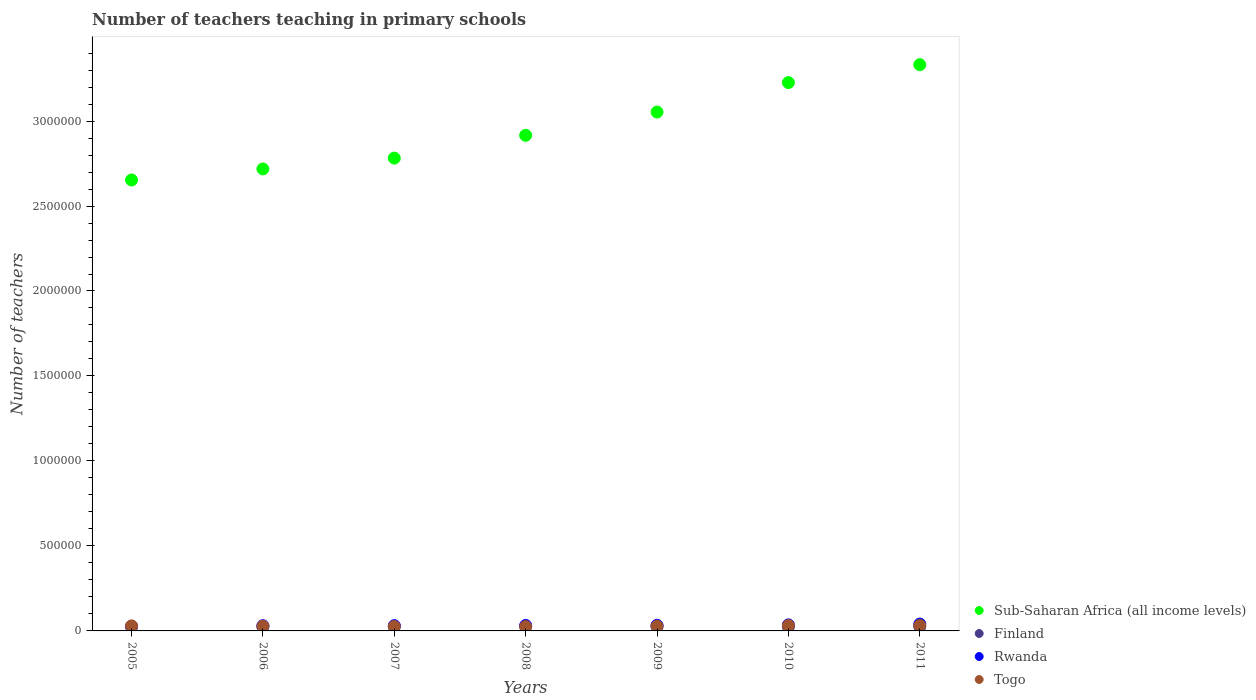How many different coloured dotlines are there?
Provide a succinct answer. 4. What is the number of teachers teaching in primary schools in Togo in 2010?
Your answer should be very brief. 3.17e+04. Across all years, what is the maximum number of teachers teaching in primary schools in Sub-Saharan Africa (all income levels)?
Give a very brief answer. 3.33e+06. Across all years, what is the minimum number of teachers teaching in primary schools in Finland?
Provide a succinct answer. 2.43e+04. In which year was the number of teachers teaching in primary schools in Rwanda maximum?
Offer a terse response. 2011. In which year was the number of teachers teaching in primary schools in Sub-Saharan Africa (all income levels) minimum?
Offer a very short reply. 2005. What is the total number of teachers teaching in primary schools in Rwanda in the graph?
Make the answer very short. 2.30e+05. What is the difference between the number of teachers teaching in primary schools in Togo in 2006 and that in 2010?
Give a very brief answer. -3709. What is the difference between the number of teachers teaching in primary schools in Finland in 2011 and the number of teachers teaching in primary schools in Sub-Saharan Africa (all income levels) in 2010?
Make the answer very short. -3.20e+06. What is the average number of teachers teaching in primary schools in Rwanda per year?
Provide a short and direct response. 3.29e+04. In the year 2010, what is the difference between the number of teachers teaching in primary schools in Finland and number of teachers teaching in primary schools in Togo?
Provide a succinct answer. -6976. What is the ratio of the number of teachers teaching in primary schools in Togo in 2007 to that in 2008?
Provide a succinct answer. 1.02. Is the difference between the number of teachers teaching in primary schools in Finland in 2007 and 2011 greater than the difference between the number of teachers teaching in primary schools in Togo in 2007 and 2011?
Offer a terse response. Yes. What is the difference between the highest and the second highest number of teachers teaching in primary schools in Togo?
Your response must be concise. 31. What is the difference between the highest and the lowest number of teachers teaching in primary schools in Togo?
Make the answer very short. 6205. Is the sum of the number of teachers teaching in primary schools in Sub-Saharan Africa (all income levels) in 2005 and 2009 greater than the maximum number of teachers teaching in primary schools in Rwanda across all years?
Offer a terse response. Yes. Is it the case that in every year, the sum of the number of teachers teaching in primary schools in Rwanda and number of teachers teaching in primary schools in Finland  is greater than the sum of number of teachers teaching in primary schools in Togo and number of teachers teaching in primary schools in Sub-Saharan Africa (all income levels)?
Give a very brief answer. No. Is it the case that in every year, the sum of the number of teachers teaching in primary schools in Finland and number of teachers teaching in primary schools in Togo  is greater than the number of teachers teaching in primary schools in Rwanda?
Your response must be concise. Yes. Is the number of teachers teaching in primary schools in Togo strictly less than the number of teachers teaching in primary schools in Finland over the years?
Give a very brief answer. No. How many dotlines are there?
Your answer should be very brief. 4. How many years are there in the graph?
Offer a terse response. 7. Does the graph contain any zero values?
Keep it short and to the point. No. Does the graph contain grids?
Ensure brevity in your answer.  No. What is the title of the graph?
Make the answer very short. Number of teachers teaching in primary schools. Does "Gambia, The" appear as one of the legend labels in the graph?
Ensure brevity in your answer.  No. What is the label or title of the Y-axis?
Your answer should be very brief. Number of teachers. What is the Number of teachers in Sub-Saharan Africa (all income levels) in 2005?
Provide a succinct answer. 2.65e+06. What is the Number of teachers of Finland in 2005?
Offer a very short reply. 2.46e+04. What is the Number of teachers in Rwanda in 2005?
Provide a short and direct response. 2.69e+04. What is the Number of teachers in Togo in 2005?
Offer a very short reply. 2.97e+04. What is the Number of teachers in Sub-Saharan Africa (all income levels) in 2006?
Your response must be concise. 2.72e+06. What is the Number of teachers of Finland in 2006?
Ensure brevity in your answer.  2.48e+04. What is the Number of teachers of Rwanda in 2006?
Offer a terse response. 3.06e+04. What is the Number of teachers of Togo in 2006?
Keep it short and to the point. 2.80e+04. What is the Number of teachers in Sub-Saharan Africa (all income levels) in 2007?
Offer a terse response. 2.78e+06. What is the Number of teachers of Finland in 2007?
Provide a succinct answer. 2.43e+04. What is the Number of teachers in Rwanda in 2007?
Make the answer very short. 3.10e+04. What is the Number of teachers in Togo in 2007?
Offer a very short reply. 2.61e+04. What is the Number of teachers in Sub-Saharan Africa (all income levels) in 2008?
Your answer should be compact. 2.92e+06. What is the Number of teachers of Finland in 2008?
Offer a very short reply. 2.48e+04. What is the Number of teachers of Rwanda in 2008?
Your answer should be compact. 3.23e+04. What is the Number of teachers of Togo in 2008?
Make the answer very short. 2.55e+04. What is the Number of teachers in Sub-Saharan Africa (all income levels) in 2009?
Offer a very short reply. 3.05e+06. What is the Number of teachers in Finland in 2009?
Your response must be concise. 2.57e+04. What is the Number of teachers in Rwanda in 2009?
Ensure brevity in your answer.  3.32e+04. What is the Number of teachers of Togo in 2009?
Ensure brevity in your answer.  2.82e+04. What is the Number of teachers in Sub-Saharan Africa (all income levels) in 2010?
Provide a succinct answer. 3.23e+06. What is the Number of teachers of Finland in 2010?
Your answer should be very brief. 2.47e+04. What is the Number of teachers of Rwanda in 2010?
Ensure brevity in your answer.  3.56e+04. What is the Number of teachers of Togo in 2010?
Offer a very short reply. 3.17e+04. What is the Number of teachers in Sub-Saharan Africa (all income levels) in 2011?
Make the answer very short. 3.33e+06. What is the Number of teachers in Finland in 2011?
Your answer should be compact. 2.53e+04. What is the Number of teachers in Rwanda in 2011?
Provide a short and direct response. 4.03e+04. What is the Number of teachers in Togo in 2011?
Offer a very short reply. 3.17e+04. Across all years, what is the maximum Number of teachers in Sub-Saharan Africa (all income levels)?
Offer a very short reply. 3.33e+06. Across all years, what is the maximum Number of teachers of Finland?
Your answer should be very brief. 2.57e+04. Across all years, what is the maximum Number of teachers in Rwanda?
Provide a short and direct response. 4.03e+04. Across all years, what is the maximum Number of teachers in Togo?
Provide a succinct answer. 3.17e+04. Across all years, what is the minimum Number of teachers of Sub-Saharan Africa (all income levels)?
Provide a short and direct response. 2.65e+06. Across all years, what is the minimum Number of teachers of Finland?
Your answer should be very brief. 2.43e+04. Across all years, what is the minimum Number of teachers in Rwanda?
Provide a succinct answer. 2.69e+04. Across all years, what is the minimum Number of teachers of Togo?
Offer a terse response. 2.55e+04. What is the total Number of teachers in Sub-Saharan Africa (all income levels) in the graph?
Provide a succinct answer. 2.07e+07. What is the total Number of teachers in Finland in the graph?
Provide a short and direct response. 1.74e+05. What is the total Number of teachers in Rwanda in the graph?
Your answer should be compact. 2.30e+05. What is the total Number of teachers of Togo in the graph?
Offer a terse response. 2.01e+05. What is the difference between the Number of teachers of Sub-Saharan Africa (all income levels) in 2005 and that in 2006?
Your answer should be very brief. -6.51e+04. What is the difference between the Number of teachers of Finland in 2005 and that in 2006?
Make the answer very short. -216. What is the difference between the Number of teachers in Rwanda in 2005 and that in 2006?
Give a very brief answer. -3693. What is the difference between the Number of teachers in Togo in 2005 and that in 2006?
Give a very brief answer. 1665. What is the difference between the Number of teachers in Sub-Saharan Africa (all income levels) in 2005 and that in 2007?
Offer a very short reply. -1.29e+05. What is the difference between the Number of teachers of Finland in 2005 and that in 2007?
Provide a succinct answer. 305. What is the difference between the Number of teachers in Rwanda in 2005 and that in 2007?
Your answer should be compact. -4093. What is the difference between the Number of teachers in Togo in 2005 and that in 2007?
Your answer should be compact. 3565. What is the difference between the Number of teachers of Sub-Saharan Africa (all income levels) in 2005 and that in 2008?
Keep it short and to the point. -2.63e+05. What is the difference between the Number of teachers in Finland in 2005 and that in 2008?
Make the answer very short. -253. What is the difference between the Number of teachers of Rwanda in 2005 and that in 2008?
Your answer should be compact. -5394. What is the difference between the Number of teachers in Togo in 2005 and that in 2008?
Provide a short and direct response. 4130. What is the difference between the Number of teachers in Sub-Saharan Africa (all income levels) in 2005 and that in 2009?
Your answer should be very brief. -4.00e+05. What is the difference between the Number of teachers of Finland in 2005 and that in 2009?
Your answer should be very brief. -1151. What is the difference between the Number of teachers of Rwanda in 2005 and that in 2009?
Offer a terse response. -6214. What is the difference between the Number of teachers of Togo in 2005 and that in 2009?
Provide a succinct answer. 1515. What is the difference between the Number of teachers in Sub-Saharan Africa (all income levels) in 2005 and that in 2010?
Give a very brief answer. -5.73e+05. What is the difference between the Number of teachers of Finland in 2005 and that in 2010?
Keep it short and to the point. -159. What is the difference between the Number of teachers of Rwanda in 2005 and that in 2010?
Provide a succinct answer. -8639. What is the difference between the Number of teachers of Togo in 2005 and that in 2010?
Offer a terse response. -2044. What is the difference between the Number of teachers of Sub-Saharan Africa (all income levels) in 2005 and that in 2011?
Keep it short and to the point. -6.78e+05. What is the difference between the Number of teachers in Finland in 2005 and that in 2011?
Your answer should be compact. -704. What is the difference between the Number of teachers in Rwanda in 2005 and that in 2011?
Make the answer very short. -1.34e+04. What is the difference between the Number of teachers in Togo in 2005 and that in 2011?
Provide a short and direct response. -2075. What is the difference between the Number of teachers in Sub-Saharan Africa (all income levels) in 2006 and that in 2007?
Keep it short and to the point. -6.36e+04. What is the difference between the Number of teachers in Finland in 2006 and that in 2007?
Keep it short and to the point. 521. What is the difference between the Number of teachers of Rwanda in 2006 and that in 2007?
Your answer should be very brief. -400. What is the difference between the Number of teachers of Togo in 2006 and that in 2007?
Keep it short and to the point. 1900. What is the difference between the Number of teachers of Sub-Saharan Africa (all income levels) in 2006 and that in 2008?
Offer a terse response. -1.98e+05. What is the difference between the Number of teachers of Finland in 2006 and that in 2008?
Keep it short and to the point. -37. What is the difference between the Number of teachers in Rwanda in 2006 and that in 2008?
Give a very brief answer. -1701. What is the difference between the Number of teachers of Togo in 2006 and that in 2008?
Ensure brevity in your answer.  2465. What is the difference between the Number of teachers in Sub-Saharan Africa (all income levels) in 2006 and that in 2009?
Your answer should be compact. -3.35e+05. What is the difference between the Number of teachers of Finland in 2006 and that in 2009?
Make the answer very short. -935. What is the difference between the Number of teachers in Rwanda in 2006 and that in 2009?
Your response must be concise. -2521. What is the difference between the Number of teachers of Togo in 2006 and that in 2009?
Your answer should be very brief. -150. What is the difference between the Number of teachers in Sub-Saharan Africa (all income levels) in 2006 and that in 2010?
Give a very brief answer. -5.08e+05. What is the difference between the Number of teachers in Finland in 2006 and that in 2010?
Your answer should be very brief. 57. What is the difference between the Number of teachers in Rwanda in 2006 and that in 2010?
Your answer should be compact. -4946. What is the difference between the Number of teachers of Togo in 2006 and that in 2010?
Your answer should be compact. -3709. What is the difference between the Number of teachers of Sub-Saharan Africa (all income levels) in 2006 and that in 2011?
Your response must be concise. -6.13e+05. What is the difference between the Number of teachers of Finland in 2006 and that in 2011?
Offer a terse response. -488. What is the difference between the Number of teachers of Rwanda in 2006 and that in 2011?
Give a very brief answer. -9662. What is the difference between the Number of teachers of Togo in 2006 and that in 2011?
Offer a very short reply. -3740. What is the difference between the Number of teachers in Sub-Saharan Africa (all income levels) in 2007 and that in 2008?
Offer a terse response. -1.34e+05. What is the difference between the Number of teachers of Finland in 2007 and that in 2008?
Provide a succinct answer. -558. What is the difference between the Number of teachers of Rwanda in 2007 and that in 2008?
Offer a terse response. -1301. What is the difference between the Number of teachers in Togo in 2007 and that in 2008?
Your response must be concise. 565. What is the difference between the Number of teachers of Sub-Saharan Africa (all income levels) in 2007 and that in 2009?
Offer a terse response. -2.71e+05. What is the difference between the Number of teachers of Finland in 2007 and that in 2009?
Your answer should be very brief. -1456. What is the difference between the Number of teachers of Rwanda in 2007 and that in 2009?
Offer a very short reply. -2121. What is the difference between the Number of teachers of Togo in 2007 and that in 2009?
Your answer should be very brief. -2050. What is the difference between the Number of teachers of Sub-Saharan Africa (all income levels) in 2007 and that in 2010?
Your answer should be compact. -4.44e+05. What is the difference between the Number of teachers of Finland in 2007 and that in 2010?
Give a very brief answer. -464. What is the difference between the Number of teachers in Rwanda in 2007 and that in 2010?
Provide a succinct answer. -4546. What is the difference between the Number of teachers of Togo in 2007 and that in 2010?
Provide a short and direct response. -5609. What is the difference between the Number of teachers in Sub-Saharan Africa (all income levels) in 2007 and that in 2011?
Offer a terse response. -5.50e+05. What is the difference between the Number of teachers in Finland in 2007 and that in 2011?
Your answer should be very brief. -1009. What is the difference between the Number of teachers of Rwanda in 2007 and that in 2011?
Offer a terse response. -9262. What is the difference between the Number of teachers of Togo in 2007 and that in 2011?
Your answer should be very brief. -5640. What is the difference between the Number of teachers of Sub-Saharan Africa (all income levels) in 2008 and that in 2009?
Give a very brief answer. -1.37e+05. What is the difference between the Number of teachers in Finland in 2008 and that in 2009?
Your answer should be very brief. -898. What is the difference between the Number of teachers in Rwanda in 2008 and that in 2009?
Ensure brevity in your answer.  -820. What is the difference between the Number of teachers of Togo in 2008 and that in 2009?
Make the answer very short. -2615. What is the difference between the Number of teachers of Sub-Saharan Africa (all income levels) in 2008 and that in 2010?
Give a very brief answer. -3.10e+05. What is the difference between the Number of teachers of Finland in 2008 and that in 2010?
Provide a succinct answer. 94. What is the difference between the Number of teachers of Rwanda in 2008 and that in 2010?
Your response must be concise. -3245. What is the difference between the Number of teachers in Togo in 2008 and that in 2010?
Make the answer very short. -6174. What is the difference between the Number of teachers of Sub-Saharan Africa (all income levels) in 2008 and that in 2011?
Keep it short and to the point. -4.15e+05. What is the difference between the Number of teachers of Finland in 2008 and that in 2011?
Ensure brevity in your answer.  -451. What is the difference between the Number of teachers of Rwanda in 2008 and that in 2011?
Keep it short and to the point. -7961. What is the difference between the Number of teachers of Togo in 2008 and that in 2011?
Provide a succinct answer. -6205. What is the difference between the Number of teachers in Sub-Saharan Africa (all income levels) in 2009 and that in 2010?
Offer a very short reply. -1.73e+05. What is the difference between the Number of teachers in Finland in 2009 and that in 2010?
Offer a terse response. 992. What is the difference between the Number of teachers in Rwanda in 2009 and that in 2010?
Offer a terse response. -2425. What is the difference between the Number of teachers of Togo in 2009 and that in 2010?
Offer a terse response. -3559. What is the difference between the Number of teachers in Sub-Saharan Africa (all income levels) in 2009 and that in 2011?
Keep it short and to the point. -2.79e+05. What is the difference between the Number of teachers of Finland in 2009 and that in 2011?
Your answer should be very brief. 447. What is the difference between the Number of teachers of Rwanda in 2009 and that in 2011?
Make the answer very short. -7141. What is the difference between the Number of teachers in Togo in 2009 and that in 2011?
Provide a short and direct response. -3590. What is the difference between the Number of teachers in Sub-Saharan Africa (all income levels) in 2010 and that in 2011?
Provide a short and direct response. -1.05e+05. What is the difference between the Number of teachers of Finland in 2010 and that in 2011?
Your answer should be very brief. -545. What is the difference between the Number of teachers in Rwanda in 2010 and that in 2011?
Your answer should be very brief. -4716. What is the difference between the Number of teachers in Togo in 2010 and that in 2011?
Keep it short and to the point. -31. What is the difference between the Number of teachers of Sub-Saharan Africa (all income levels) in 2005 and the Number of teachers of Finland in 2006?
Provide a short and direct response. 2.63e+06. What is the difference between the Number of teachers of Sub-Saharan Africa (all income levels) in 2005 and the Number of teachers of Rwanda in 2006?
Your response must be concise. 2.62e+06. What is the difference between the Number of teachers in Sub-Saharan Africa (all income levels) in 2005 and the Number of teachers in Togo in 2006?
Your answer should be very brief. 2.63e+06. What is the difference between the Number of teachers of Finland in 2005 and the Number of teachers of Rwanda in 2006?
Give a very brief answer. -6060. What is the difference between the Number of teachers of Finland in 2005 and the Number of teachers of Togo in 2006?
Keep it short and to the point. -3426. What is the difference between the Number of teachers in Rwanda in 2005 and the Number of teachers in Togo in 2006?
Keep it short and to the point. -1059. What is the difference between the Number of teachers in Sub-Saharan Africa (all income levels) in 2005 and the Number of teachers in Finland in 2007?
Make the answer very short. 2.63e+06. What is the difference between the Number of teachers in Sub-Saharan Africa (all income levels) in 2005 and the Number of teachers in Rwanda in 2007?
Offer a terse response. 2.62e+06. What is the difference between the Number of teachers of Sub-Saharan Africa (all income levels) in 2005 and the Number of teachers of Togo in 2007?
Make the answer very short. 2.63e+06. What is the difference between the Number of teachers in Finland in 2005 and the Number of teachers in Rwanda in 2007?
Offer a very short reply. -6460. What is the difference between the Number of teachers in Finland in 2005 and the Number of teachers in Togo in 2007?
Give a very brief answer. -1526. What is the difference between the Number of teachers of Rwanda in 2005 and the Number of teachers of Togo in 2007?
Provide a succinct answer. 841. What is the difference between the Number of teachers of Sub-Saharan Africa (all income levels) in 2005 and the Number of teachers of Finland in 2008?
Your answer should be very brief. 2.63e+06. What is the difference between the Number of teachers of Sub-Saharan Africa (all income levels) in 2005 and the Number of teachers of Rwanda in 2008?
Your response must be concise. 2.62e+06. What is the difference between the Number of teachers in Sub-Saharan Africa (all income levels) in 2005 and the Number of teachers in Togo in 2008?
Your answer should be compact. 2.63e+06. What is the difference between the Number of teachers of Finland in 2005 and the Number of teachers of Rwanda in 2008?
Provide a succinct answer. -7761. What is the difference between the Number of teachers of Finland in 2005 and the Number of teachers of Togo in 2008?
Keep it short and to the point. -961. What is the difference between the Number of teachers in Rwanda in 2005 and the Number of teachers in Togo in 2008?
Give a very brief answer. 1406. What is the difference between the Number of teachers in Sub-Saharan Africa (all income levels) in 2005 and the Number of teachers in Finland in 2009?
Make the answer very short. 2.63e+06. What is the difference between the Number of teachers in Sub-Saharan Africa (all income levels) in 2005 and the Number of teachers in Rwanda in 2009?
Your answer should be very brief. 2.62e+06. What is the difference between the Number of teachers of Sub-Saharan Africa (all income levels) in 2005 and the Number of teachers of Togo in 2009?
Offer a terse response. 2.63e+06. What is the difference between the Number of teachers of Finland in 2005 and the Number of teachers of Rwanda in 2009?
Give a very brief answer. -8581. What is the difference between the Number of teachers in Finland in 2005 and the Number of teachers in Togo in 2009?
Provide a short and direct response. -3576. What is the difference between the Number of teachers of Rwanda in 2005 and the Number of teachers of Togo in 2009?
Offer a terse response. -1209. What is the difference between the Number of teachers in Sub-Saharan Africa (all income levels) in 2005 and the Number of teachers in Finland in 2010?
Your response must be concise. 2.63e+06. What is the difference between the Number of teachers in Sub-Saharan Africa (all income levels) in 2005 and the Number of teachers in Rwanda in 2010?
Ensure brevity in your answer.  2.62e+06. What is the difference between the Number of teachers in Sub-Saharan Africa (all income levels) in 2005 and the Number of teachers in Togo in 2010?
Ensure brevity in your answer.  2.62e+06. What is the difference between the Number of teachers of Finland in 2005 and the Number of teachers of Rwanda in 2010?
Make the answer very short. -1.10e+04. What is the difference between the Number of teachers of Finland in 2005 and the Number of teachers of Togo in 2010?
Ensure brevity in your answer.  -7135. What is the difference between the Number of teachers in Rwanda in 2005 and the Number of teachers in Togo in 2010?
Provide a succinct answer. -4768. What is the difference between the Number of teachers of Sub-Saharan Africa (all income levels) in 2005 and the Number of teachers of Finland in 2011?
Offer a very short reply. 2.63e+06. What is the difference between the Number of teachers of Sub-Saharan Africa (all income levels) in 2005 and the Number of teachers of Rwanda in 2011?
Make the answer very short. 2.61e+06. What is the difference between the Number of teachers of Sub-Saharan Africa (all income levels) in 2005 and the Number of teachers of Togo in 2011?
Your answer should be very brief. 2.62e+06. What is the difference between the Number of teachers of Finland in 2005 and the Number of teachers of Rwanda in 2011?
Offer a very short reply. -1.57e+04. What is the difference between the Number of teachers in Finland in 2005 and the Number of teachers in Togo in 2011?
Provide a succinct answer. -7166. What is the difference between the Number of teachers of Rwanda in 2005 and the Number of teachers of Togo in 2011?
Make the answer very short. -4799. What is the difference between the Number of teachers of Sub-Saharan Africa (all income levels) in 2006 and the Number of teachers of Finland in 2007?
Provide a short and direct response. 2.69e+06. What is the difference between the Number of teachers of Sub-Saharan Africa (all income levels) in 2006 and the Number of teachers of Rwanda in 2007?
Offer a very short reply. 2.69e+06. What is the difference between the Number of teachers in Sub-Saharan Africa (all income levels) in 2006 and the Number of teachers in Togo in 2007?
Ensure brevity in your answer.  2.69e+06. What is the difference between the Number of teachers in Finland in 2006 and the Number of teachers in Rwanda in 2007?
Make the answer very short. -6244. What is the difference between the Number of teachers of Finland in 2006 and the Number of teachers of Togo in 2007?
Keep it short and to the point. -1310. What is the difference between the Number of teachers of Rwanda in 2006 and the Number of teachers of Togo in 2007?
Give a very brief answer. 4534. What is the difference between the Number of teachers of Sub-Saharan Africa (all income levels) in 2006 and the Number of teachers of Finland in 2008?
Provide a succinct answer. 2.69e+06. What is the difference between the Number of teachers of Sub-Saharan Africa (all income levels) in 2006 and the Number of teachers of Rwanda in 2008?
Provide a succinct answer. 2.69e+06. What is the difference between the Number of teachers in Sub-Saharan Africa (all income levels) in 2006 and the Number of teachers in Togo in 2008?
Make the answer very short. 2.69e+06. What is the difference between the Number of teachers in Finland in 2006 and the Number of teachers in Rwanda in 2008?
Your response must be concise. -7545. What is the difference between the Number of teachers of Finland in 2006 and the Number of teachers of Togo in 2008?
Offer a very short reply. -745. What is the difference between the Number of teachers of Rwanda in 2006 and the Number of teachers of Togo in 2008?
Give a very brief answer. 5099. What is the difference between the Number of teachers of Sub-Saharan Africa (all income levels) in 2006 and the Number of teachers of Finland in 2009?
Your response must be concise. 2.69e+06. What is the difference between the Number of teachers of Sub-Saharan Africa (all income levels) in 2006 and the Number of teachers of Rwanda in 2009?
Provide a short and direct response. 2.69e+06. What is the difference between the Number of teachers of Sub-Saharan Africa (all income levels) in 2006 and the Number of teachers of Togo in 2009?
Make the answer very short. 2.69e+06. What is the difference between the Number of teachers of Finland in 2006 and the Number of teachers of Rwanda in 2009?
Provide a succinct answer. -8365. What is the difference between the Number of teachers of Finland in 2006 and the Number of teachers of Togo in 2009?
Your answer should be compact. -3360. What is the difference between the Number of teachers in Rwanda in 2006 and the Number of teachers in Togo in 2009?
Give a very brief answer. 2484. What is the difference between the Number of teachers of Sub-Saharan Africa (all income levels) in 2006 and the Number of teachers of Finland in 2010?
Give a very brief answer. 2.69e+06. What is the difference between the Number of teachers in Sub-Saharan Africa (all income levels) in 2006 and the Number of teachers in Rwanda in 2010?
Your answer should be very brief. 2.68e+06. What is the difference between the Number of teachers of Sub-Saharan Africa (all income levels) in 2006 and the Number of teachers of Togo in 2010?
Keep it short and to the point. 2.69e+06. What is the difference between the Number of teachers in Finland in 2006 and the Number of teachers in Rwanda in 2010?
Offer a very short reply. -1.08e+04. What is the difference between the Number of teachers in Finland in 2006 and the Number of teachers in Togo in 2010?
Offer a terse response. -6919. What is the difference between the Number of teachers in Rwanda in 2006 and the Number of teachers in Togo in 2010?
Offer a terse response. -1075. What is the difference between the Number of teachers of Sub-Saharan Africa (all income levels) in 2006 and the Number of teachers of Finland in 2011?
Your answer should be compact. 2.69e+06. What is the difference between the Number of teachers in Sub-Saharan Africa (all income levels) in 2006 and the Number of teachers in Rwanda in 2011?
Your answer should be compact. 2.68e+06. What is the difference between the Number of teachers in Sub-Saharan Africa (all income levels) in 2006 and the Number of teachers in Togo in 2011?
Your answer should be very brief. 2.69e+06. What is the difference between the Number of teachers of Finland in 2006 and the Number of teachers of Rwanda in 2011?
Your response must be concise. -1.55e+04. What is the difference between the Number of teachers in Finland in 2006 and the Number of teachers in Togo in 2011?
Keep it short and to the point. -6950. What is the difference between the Number of teachers of Rwanda in 2006 and the Number of teachers of Togo in 2011?
Provide a succinct answer. -1106. What is the difference between the Number of teachers of Sub-Saharan Africa (all income levels) in 2007 and the Number of teachers of Finland in 2008?
Ensure brevity in your answer.  2.76e+06. What is the difference between the Number of teachers in Sub-Saharan Africa (all income levels) in 2007 and the Number of teachers in Rwanda in 2008?
Offer a terse response. 2.75e+06. What is the difference between the Number of teachers of Sub-Saharan Africa (all income levels) in 2007 and the Number of teachers of Togo in 2008?
Provide a short and direct response. 2.76e+06. What is the difference between the Number of teachers in Finland in 2007 and the Number of teachers in Rwanda in 2008?
Your answer should be compact. -8066. What is the difference between the Number of teachers in Finland in 2007 and the Number of teachers in Togo in 2008?
Keep it short and to the point. -1266. What is the difference between the Number of teachers of Rwanda in 2007 and the Number of teachers of Togo in 2008?
Provide a succinct answer. 5499. What is the difference between the Number of teachers in Sub-Saharan Africa (all income levels) in 2007 and the Number of teachers in Finland in 2009?
Provide a short and direct response. 2.76e+06. What is the difference between the Number of teachers of Sub-Saharan Africa (all income levels) in 2007 and the Number of teachers of Rwanda in 2009?
Offer a very short reply. 2.75e+06. What is the difference between the Number of teachers of Sub-Saharan Africa (all income levels) in 2007 and the Number of teachers of Togo in 2009?
Your answer should be very brief. 2.75e+06. What is the difference between the Number of teachers of Finland in 2007 and the Number of teachers of Rwanda in 2009?
Keep it short and to the point. -8886. What is the difference between the Number of teachers in Finland in 2007 and the Number of teachers in Togo in 2009?
Provide a succinct answer. -3881. What is the difference between the Number of teachers in Rwanda in 2007 and the Number of teachers in Togo in 2009?
Your response must be concise. 2884. What is the difference between the Number of teachers of Sub-Saharan Africa (all income levels) in 2007 and the Number of teachers of Finland in 2010?
Offer a terse response. 2.76e+06. What is the difference between the Number of teachers in Sub-Saharan Africa (all income levels) in 2007 and the Number of teachers in Rwanda in 2010?
Provide a short and direct response. 2.75e+06. What is the difference between the Number of teachers in Sub-Saharan Africa (all income levels) in 2007 and the Number of teachers in Togo in 2010?
Make the answer very short. 2.75e+06. What is the difference between the Number of teachers in Finland in 2007 and the Number of teachers in Rwanda in 2010?
Keep it short and to the point. -1.13e+04. What is the difference between the Number of teachers in Finland in 2007 and the Number of teachers in Togo in 2010?
Provide a succinct answer. -7440. What is the difference between the Number of teachers in Rwanda in 2007 and the Number of teachers in Togo in 2010?
Your answer should be compact. -675. What is the difference between the Number of teachers in Sub-Saharan Africa (all income levels) in 2007 and the Number of teachers in Finland in 2011?
Provide a succinct answer. 2.76e+06. What is the difference between the Number of teachers of Sub-Saharan Africa (all income levels) in 2007 and the Number of teachers of Rwanda in 2011?
Offer a terse response. 2.74e+06. What is the difference between the Number of teachers in Sub-Saharan Africa (all income levels) in 2007 and the Number of teachers in Togo in 2011?
Give a very brief answer. 2.75e+06. What is the difference between the Number of teachers of Finland in 2007 and the Number of teachers of Rwanda in 2011?
Your answer should be compact. -1.60e+04. What is the difference between the Number of teachers of Finland in 2007 and the Number of teachers of Togo in 2011?
Offer a terse response. -7471. What is the difference between the Number of teachers of Rwanda in 2007 and the Number of teachers of Togo in 2011?
Your response must be concise. -706. What is the difference between the Number of teachers of Sub-Saharan Africa (all income levels) in 2008 and the Number of teachers of Finland in 2009?
Offer a very short reply. 2.89e+06. What is the difference between the Number of teachers of Sub-Saharan Africa (all income levels) in 2008 and the Number of teachers of Rwanda in 2009?
Keep it short and to the point. 2.88e+06. What is the difference between the Number of teachers in Sub-Saharan Africa (all income levels) in 2008 and the Number of teachers in Togo in 2009?
Your answer should be compact. 2.89e+06. What is the difference between the Number of teachers of Finland in 2008 and the Number of teachers of Rwanda in 2009?
Provide a short and direct response. -8328. What is the difference between the Number of teachers in Finland in 2008 and the Number of teachers in Togo in 2009?
Offer a very short reply. -3323. What is the difference between the Number of teachers of Rwanda in 2008 and the Number of teachers of Togo in 2009?
Offer a terse response. 4185. What is the difference between the Number of teachers of Sub-Saharan Africa (all income levels) in 2008 and the Number of teachers of Finland in 2010?
Provide a short and direct response. 2.89e+06. What is the difference between the Number of teachers in Sub-Saharan Africa (all income levels) in 2008 and the Number of teachers in Rwanda in 2010?
Your response must be concise. 2.88e+06. What is the difference between the Number of teachers of Sub-Saharan Africa (all income levels) in 2008 and the Number of teachers of Togo in 2010?
Provide a succinct answer. 2.88e+06. What is the difference between the Number of teachers in Finland in 2008 and the Number of teachers in Rwanda in 2010?
Make the answer very short. -1.08e+04. What is the difference between the Number of teachers in Finland in 2008 and the Number of teachers in Togo in 2010?
Provide a short and direct response. -6882. What is the difference between the Number of teachers of Rwanda in 2008 and the Number of teachers of Togo in 2010?
Keep it short and to the point. 626. What is the difference between the Number of teachers in Sub-Saharan Africa (all income levels) in 2008 and the Number of teachers in Finland in 2011?
Provide a succinct answer. 2.89e+06. What is the difference between the Number of teachers in Sub-Saharan Africa (all income levels) in 2008 and the Number of teachers in Rwanda in 2011?
Your answer should be very brief. 2.88e+06. What is the difference between the Number of teachers in Sub-Saharan Africa (all income levels) in 2008 and the Number of teachers in Togo in 2011?
Keep it short and to the point. 2.88e+06. What is the difference between the Number of teachers of Finland in 2008 and the Number of teachers of Rwanda in 2011?
Your answer should be compact. -1.55e+04. What is the difference between the Number of teachers in Finland in 2008 and the Number of teachers in Togo in 2011?
Give a very brief answer. -6913. What is the difference between the Number of teachers in Rwanda in 2008 and the Number of teachers in Togo in 2011?
Provide a short and direct response. 595. What is the difference between the Number of teachers in Sub-Saharan Africa (all income levels) in 2009 and the Number of teachers in Finland in 2010?
Give a very brief answer. 3.03e+06. What is the difference between the Number of teachers in Sub-Saharan Africa (all income levels) in 2009 and the Number of teachers in Rwanda in 2010?
Make the answer very short. 3.02e+06. What is the difference between the Number of teachers of Sub-Saharan Africa (all income levels) in 2009 and the Number of teachers of Togo in 2010?
Give a very brief answer. 3.02e+06. What is the difference between the Number of teachers of Finland in 2009 and the Number of teachers of Rwanda in 2010?
Your response must be concise. -9855. What is the difference between the Number of teachers of Finland in 2009 and the Number of teachers of Togo in 2010?
Give a very brief answer. -5984. What is the difference between the Number of teachers in Rwanda in 2009 and the Number of teachers in Togo in 2010?
Provide a short and direct response. 1446. What is the difference between the Number of teachers in Sub-Saharan Africa (all income levels) in 2009 and the Number of teachers in Finland in 2011?
Offer a very short reply. 3.03e+06. What is the difference between the Number of teachers in Sub-Saharan Africa (all income levels) in 2009 and the Number of teachers in Rwanda in 2011?
Ensure brevity in your answer.  3.01e+06. What is the difference between the Number of teachers in Sub-Saharan Africa (all income levels) in 2009 and the Number of teachers in Togo in 2011?
Offer a terse response. 3.02e+06. What is the difference between the Number of teachers in Finland in 2009 and the Number of teachers in Rwanda in 2011?
Give a very brief answer. -1.46e+04. What is the difference between the Number of teachers of Finland in 2009 and the Number of teachers of Togo in 2011?
Provide a short and direct response. -6015. What is the difference between the Number of teachers in Rwanda in 2009 and the Number of teachers in Togo in 2011?
Ensure brevity in your answer.  1415. What is the difference between the Number of teachers in Sub-Saharan Africa (all income levels) in 2010 and the Number of teachers in Finland in 2011?
Provide a succinct answer. 3.20e+06. What is the difference between the Number of teachers in Sub-Saharan Africa (all income levels) in 2010 and the Number of teachers in Rwanda in 2011?
Ensure brevity in your answer.  3.19e+06. What is the difference between the Number of teachers of Sub-Saharan Africa (all income levels) in 2010 and the Number of teachers of Togo in 2011?
Ensure brevity in your answer.  3.19e+06. What is the difference between the Number of teachers of Finland in 2010 and the Number of teachers of Rwanda in 2011?
Give a very brief answer. -1.56e+04. What is the difference between the Number of teachers in Finland in 2010 and the Number of teachers in Togo in 2011?
Keep it short and to the point. -7007. What is the difference between the Number of teachers in Rwanda in 2010 and the Number of teachers in Togo in 2011?
Ensure brevity in your answer.  3840. What is the average Number of teachers of Sub-Saharan Africa (all income levels) per year?
Make the answer very short. 2.95e+06. What is the average Number of teachers in Finland per year?
Keep it short and to the point. 2.49e+04. What is the average Number of teachers in Rwanda per year?
Your answer should be compact. 3.29e+04. What is the average Number of teachers of Togo per year?
Your response must be concise. 2.87e+04. In the year 2005, what is the difference between the Number of teachers of Sub-Saharan Africa (all income levels) and Number of teachers of Finland?
Your answer should be compact. 2.63e+06. In the year 2005, what is the difference between the Number of teachers of Sub-Saharan Africa (all income levels) and Number of teachers of Rwanda?
Offer a terse response. 2.63e+06. In the year 2005, what is the difference between the Number of teachers in Sub-Saharan Africa (all income levels) and Number of teachers in Togo?
Make the answer very short. 2.62e+06. In the year 2005, what is the difference between the Number of teachers in Finland and Number of teachers in Rwanda?
Your answer should be very brief. -2367. In the year 2005, what is the difference between the Number of teachers of Finland and Number of teachers of Togo?
Provide a succinct answer. -5091. In the year 2005, what is the difference between the Number of teachers in Rwanda and Number of teachers in Togo?
Provide a short and direct response. -2724. In the year 2006, what is the difference between the Number of teachers of Sub-Saharan Africa (all income levels) and Number of teachers of Finland?
Make the answer very short. 2.69e+06. In the year 2006, what is the difference between the Number of teachers in Sub-Saharan Africa (all income levels) and Number of teachers in Rwanda?
Your answer should be very brief. 2.69e+06. In the year 2006, what is the difference between the Number of teachers in Sub-Saharan Africa (all income levels) and Number of teachers in Togo?
Your answer should be compact. 2.69e+06. In the year 2006, what is the difference between the Number of teachers of Finland and Number of teachers of Rwanda?
Ensure brevity in your answer.  -5844. In the year 2006, what is the difference between the Number of teachers of Finland and Number of teachers of Togo?
Your response must be concise. -3210. In the year 2006, what is the difference between the Number of teachers of Rwanda and Number of teachers of Togo?
Your answer should be very brief. 2634. In the year 2007, what is the difference between the Number of teachers in Sub-Saharan Africa (all income levels) and Number of teachers in Finland?
Your response must be concise. 2.76e+06. In the year 2007, what is the difference between the Number of teachers in Sub-Saharan Africa (all income levels) and Number of teachers in Rwanda?
Provide a succinct answer. 2.75e+06. In the year 2007, what is the difference between the Number of teachers in Sub-Saharan Africa (all income levels) and Number of teachers in Togo?
Provide a short and direct response. 2.76e+06. In the year 2007, what is the difference between the Number of teachers of Finland and Number of teachers of Rwanda?
Offer a terse response. -6765. In the year 2007, what is the difference between the Number of teachers in Finland and Number of teachers in Togo?
Keep it short and to the point. -1831. In the year 2007, what is the difference between the Number of teachers in Rwanda and Number of teachers in Togo?
Ensure brevity in your answer.  4934. In the year 2008, what is the difference between the Number of teachers of Sub-Saharan Africa (all income levels) and Number of teachers of Finland?
Your answer should be very brief. 2.89e+06. In the year 2008, what is the difference between the Number of teachers in Sub-Saharan Africa (all income levels) and Number of teachers in Rwanda?
Your response must be concise. 2.88e+06. In the year 2008, what is the difference between the Number of teachers in Sub-Saharan Africa (all income levels) and Number of teachers in Togo?
Your response must be concise. 2.89e+06. In the year 2008, what is the difference between the Number of teachers of Finland and Number of teachers of Rwanda?
Your answer should be compact. -7508. In the year 2008, what is the difference between the Number of teachers of Finland and Number of teachers of Togo?
Your answer should be compact. -708. In the year 2008, what is the difference between the Number of teachers in Rwanda and Number of teachers in Togo?
Your answer should be compact. 6800. In the year 2009, what is the difference between the Number of teachers in Sub-Saharan Africa (all income levels) and Number of teachers in Finland?
Your answer should be compact. 3.03e+06. In the year 2009, what is the difference between the Number of teachers in Sub-Saharan Africa (all income levels) and Number of teachers in Rwanda?
Make the answer very short. 3.02e+06. In the year 2009, what is the difference between the Number of teachers of Sub-Saharan Africa (all income levels) and Number of teachers of Togo?
Provide a succinct answer. 3.02e+06. In the year 2009, what is the difference between the Number of teachers in Finland and Number of teachers in Rwanda?
Offer a terse response. -7430. In the year 2009, what is the difference between the Number of teachers in Finland and Number of teachers in Togo?
Provide a short and direct response. -2425. In the year 2009, what is the difference between the Number of teachers of Rwanda and Number of teachers of Togo?
Your answer should be compact. 5005. In the year 2010, what is the difference between the Number of teachers of Sub-Saharan Africa (all income levels) and Number of teachers of Finland?
Offer a terse response. 3.20e+06. In the year 2010, what is the difference between the Number of teachers in Sub-Saharan Africa (all income levels) and Number of teachers in Rwanda?
Your answer should be very brief. 3.19e+06. In the year 2010, what is the difference between the Number of teachers in Sub-Saharan Africa (all income levels) and Number of teachers in Togo?
Keep it short and to the point. 3.19e+06. In the year 2010, what is the difference between the Number of teachers of Finland and Number of teachers of Rwanda?
Keep it short and to the point. -1.08e+04. In the year 2010, what is the difference between the Number of teachers in Finland and Number of teachers in Togo?
Keep it short and to the point. -6976. In the year 2010, what is the difference between the Number of teachers in Rwanda and Number of teachers in Togo?
Provide a short and direct response. 3871. In the year 2011, what is the difference between the Number of teachers in Sub-Saharan Africa (all income levels) and Number of teachers in Finland?
Offer a terse response. 3.31e+06. In the year 2011, what is the difference between the Number of teachers in Sub-Saharan Africa (all income levels) and Number of teachers in Rwanda?
Make the answer very short. 3.29e+06. In the year 2011, what is the difference between the Number of teachers in Sub-Saharan Africa (all income levels) and Number of teachers in Togo?
Your answer should be very brief. 3.30e+06. In the year 2011, what is the difference between the Number of teachers of Finland and Number of teachers of Rwanda?
Your answer should be compact. -1.50e+04. In the year 2011, what is the difference between the Number of teachers of Finland and Number of teachers of Togo?
Offer a very short reply. -6462. In the year 2011, what is the difference between the Number of teachers of Rwanda and Number of teachers of Togo?
Offer a very short reply. 8556. What is the ratio of the Number of teachers of Sub-Saharan Africa (all income levels) in 2005 to that in 2006?
Ensure brevity in your answer.  0.98. What is the ratio of the Number of teachers in Finland in 2005 to that in 2006?
Your answer should be compact. 0.99. What is the ratio of the Number of teachers in Rwanda in 2005 to that in 2006?
Make the answer very short. 0.88. What is the ratio of the Number of teachers of Togo in 2005 to that in 2006?
Provide a short and direct response. 1.06. What is the ratio of the Number of teachers of Sub-Saharan Africa (all income levels) in 2005 to that in 2007?
Ensure brevity in your answer.  0.95. What is the ratio of the Number of teachers of Finland in 2005 to that in 2007?
Give a very brief answer. 1.01. What is the ratio of the Number of teachers of Rwanda in 2005 to that in 2007?
Make the answer very short. 0.87. What is the ratio of the Number of teachers of Togo in 2005 to that in 2007?
Offer a terse response. 1.14. What is the ratio of the Number of teachers in Sub-Saharan Africa (all income levels) in 2005 to that in 2008?
Give a very brief answer. 0.91. What is the ratio of the Number of teachers of Finland in 2005 to that in 2008?
Offer a terse response. 0.99. What is the ratio of the Number of teachers in Rwanda in 2005 to that in 2008?
Your response must be concise. 0.83. What is the ratio of the Number of teachers of Togo in 2005 to that in 2008?
Ensure brevity in your answer.  1.16. What is the ratio of the Number of teachers of Sub-Saharan Africa (all income levels) in 2005 to that in 2009?
Provide a succinct answer. 0.87. What is the ratio of the Number of teachers in Finland in 2005 to that in 2009?
Your response must be concise. 0.96. What is the ratio of the Number of teachers of Rwanda in 2005 to that in 2009?
Offer a very short reply. 0.81. What is the ratio of the Number of teachers of Togo in 2005 to that in 2009?
Give a very brief answer. 1.05. What is the ratio of the Number of teachers of Sub-Saharan Africa (all income levels) in 2005 to that in 2010?
Offer a terse response. 0.82. What is the ratio of the Number of teachers of Finland in 2005 to that in 2010?
Offer a terse response. 0.99. What is the ratio of the Number of teachers in Rwanda in 2005 to that in 2010?
Provide a short and direct response. 0.76. What is the ratio of the Number of teachers in Togo in 2005 to that in 2010?
Ensure brevity in your answer.  0.94. What is the ratio of the Number of teachers of Sub-Saharan Africa (all income levels) in 2005 to that in 2011?
Offer a very short reply. 0.8. What is the ratio of the Number of teachers in Finland in 2005 to that in 2011?
Provide a succinct answer. 0.97. What is the ratio of the Number of teachers in Rwanda in 2005 to that in 2011?
Make the answer very short. 0.67. What is the ratio of the Number of teachers of Togo in 2005 to that in 2011?
Ensure brevity in your answer.  0.93. What is the ratio of the Number of teachers of Sub-Saharan Africa (all income levels) in 2006 to that in 2007?
Provide a short and direct response. 0.98. What is the ratio of the Number of teachers in Finland in 2006 to that in 2007?
Your response must be concise. 1.02. What is the ratio of the Number of teachers in Rwanda in 2006 to that in 2007?
Offer a terse response. 0.99. What is the ratio of the Number of teachers in Togo in 2006 to that in 2007?
Your answer should be compact. 1.07. What is the ratio of the Number of teachers in Sub-Saharan Africa (all income levels) in 2006 to that in 2008?
Provide a succinct answer. 0.93. What is the ratio of the Number of teachers in Finland in 2006 to that in 2008?
Your response must be concise. 1. What is the ratio of the Number of teachers in Rwanda in 2006 to that in 2008?
Make the answer very short. 0.95. What is the ratio of the Number of teachers in Togo in 2006 to that in 2008?
Keep it short and to the point. 1.1. What is the ratio of the Number of teachers in Sub-Saharan Africa (all income levels) in 2006 to that in 2009?
Keep it short and to the point. 0.89. What is the ratio of the Number of teachers of Finland in 2006 to that in 2009?
Your response must be concise. 0.96. What is the ratio of the Number of teachers of Rwanda in 2006 to that in 2009?
Your answer should be very brief. 0.92. What is the ratio of the Number of teachers of Togo in 2006 to that in 2009?
Your answer should be very brief. 0.99. What is the ratio of the Number of teachers of Sub-Saharan Africa (all income levels) in 2006 to that in 2010?
Keep it short and to the point. 0.84. What is the ratio of the Number of teachers in Finland in 2006 to that in 2010?
Your response must be concise. 1. What is the ratio of the Number of teachers of Rwanda in 2006 to that in 2010?
Your answer should be compact. 0.86. What is the ratio of the Number of teachers in Togo in 2006 to that in 2010?
Provide a succinct answer. 0.88. What is the ratio of the Number of teachers of Sub-Saharan Africa (all income levels) in 2006 to that in 2011?
Give a very brief answer. 0.82. What is the ratio of the Number of teachers in Finland in 2006 to that in 2011?
Offer a very short reply. 0.98. What is the ratio of the Number of teachers of Rwanda in 2006 to that in 2011?
Ensure brevity in your answer.  0.76. What is the ratio of the Number of teachers in Togo in 2006 to that in 2011?
Ensure brevity in your answer.  0.88. What is the ratio of the Number of teachers in Sub-Saharan Africa (all income levels) in 2007 to that in 2008?
Make the answer very short. 0.95. What is the ratio of the Number of teachers of Finland in 2007 to that in 2008?
Provide a short and direct response. 0.98. What is the ratio of the Number of teachers of Rwanda in 2007 to that in 2008?
Your response must be concise. 0.96. What is the ratio of the Number of teachers of Togo in 2007 to that in 2008?
Offer a very short reply. 1.02. What is the ratio of the Number of teachers of Sub-Saharan Africa (all income levels) in 2007 to that in 2009?
Your answer should be compact. 0.91. What is the ratio of the Number of teachers in Finland in 2007 to that in 2009?
Offer a very short reply. 0.94. What is the ratio of the Number of teachers in Rwanda in 2007 to that in 2009?
Make the answer very short. 0.94. What is the ratio of the Number of teachers in Togo in 2007 to that in 2009?
Give a very brief answer. 0.93. What is the ratio of the Number of teachers of Sub-Saharan Africa (all income levels) in 2007 to that in 2010?
Provide a succinct answer. 0.86. What is the ratio of the Number of teachers in Finland in 2007 to that in 2010?
Your answer should be compact. 0.98. What is the ratio of the Number of teachers of Rwanda in 2007 to that in 2010?
Make the answer very short. 0.87. What is the ratio of the Number of teachers in Togo in 2007 to that in 2010?
Ensure brevity in your answer.  0.82. What is the ratio of the Number of teachers in Sub-Saharan Africa (all income levels) in 2007 to that in 2011?
Your answer should be very brief. 0.83. What is the ratio of the Number of teachers of Finland in 2007 to that in 2011?
Your answer should be very brief. 0.96. What is the ratio of the Number of teachers in Rwanda in 2007 to that in 2011?
Make the answer very short. 0.77. What is the ratio of the Number of teachers in Togo in 2007 to that in 2011?
Make the answer very short. 0.82. What is the ratio of the Number of teachers of Sub-Saharan Africa (all income levels) in 2008 to that in 2009?
Offer a very short reply. 0.96. What is the ratio of the Number of teachers of Finland in 2008 to that in 2009?
Offer a very short reply. 0.97. What is the ratio of the Number of teachers of Rwanda in 2008 to that in 2009?
Ensure brevity in your answer.  0.98. What is the ratio of the Number of teachers of Togo in 2008 to that in 2009?
Make the answer very short. 0.91. What is the ratio of the Number of teachers in Sub-Saharan Africa (all income levels) in 2008 to that in 2010?
Make the answer very short. 0.9. What is the ratio of the Number of teachers of Rwanda in 2008 to that in 2010?
Offer a terse response. 0.91. What is the ratio of the Number of teachers of Togo in 2008 to that in 2010?
Make the answer very short. 0.81. What is the ratio of the Number of teachers in Sub-Saharan Africa (all income levels) in 2008 to that in 2011?
Your answer should be very brief. 0.88. What is the ratio of the Number of teachers in Finland in 2008 to that in 2011?
Your response must be concise. 0.98. What is the ratio of the Number of teachers in Rwanda in 2008 to that in 2011?
Your response must be concise. 0.8. What is the ratio of the Number of teachers in Togo in 2008 to that in 2011?
Your answer should be compact. 0.8. What is the ratio of the Number of teachers of Sub-Saharan Africa (all income levels) in 2009 to that in 2010?
Provide a succinct answer. 0.95. What is the ratio of the Number of teachers of Finland in 2009 to that in 2010?
Offer a very short reply. 1.04. What is the ratio of the Number of teachers in Rwanda in 2009 to that in 2010?
Your answer should be compact. 0.93. What is the ratio of the Number of teachers in Togo in 2009 to that in 2010?
Your answer should be very brief. 0.89. What is the ratio of the Number of teachers of Sub-Saharan Africa (all income levels) in 2009 to that in 2011?
Ensure brevity in your answer.  0.92. What is the ratio of the Number of teachers of Finland in 2009 to that in 2011?
Your answer should be compact. 1.02. What is the ratio of the Number of teachers of Rwanda in 2009 to that in 2011?
Your answer should be very brief. 0.82. What is the ratio of the Number of teachers in Togo in 2009 to that in 2011?
Your answer should be very brief. 0.89. What is the ratio of the Number of teachers in Sub-Saharan Africa (all income levels) in 2010 to that in 2011?
Keep it short and to the point. 0.97. What is the ratio of the Number of teachers in Finland in 2010 to that in 2011?
Offer a very short reply. 0.98. What is the ratio of the Number of teachers in Rwanda in 2010 to that in 2011?
Your response must be concise. 0.88. What is the difference between the highest and the second highest Number of teachers in Sub-Saharan Africa (all income levels)?
Provide a short and direct response. 1.05e+05. What is the difference between the highest and the second highest Number of teachers of Finland?
Provide a succinct answer. 447. What is the difference between the highest and the second highest Number of teachers of Rwanda?
Your answer should be compact. 4716. What is the difference between the highest and the second highest Number of teachers of Togo?
Keep it short and to the point. 31. What is the difference between the highest and the lowest Number of teachers of Sub-Saharan Africa (all income levels)?
Offer a terse response. 6.78e+05. What is the difference between the highest and the lowest Number of teachers in Finland?
Offer a terse response. 1456. What is the difference between the highest and the lowest Number of teachers of Rwanda?
Offer a very short reply. 1.34e+04. What is the difference between the highest and the lowest Number of teachers of Togo?
Provide a succinct answer. 6205. 